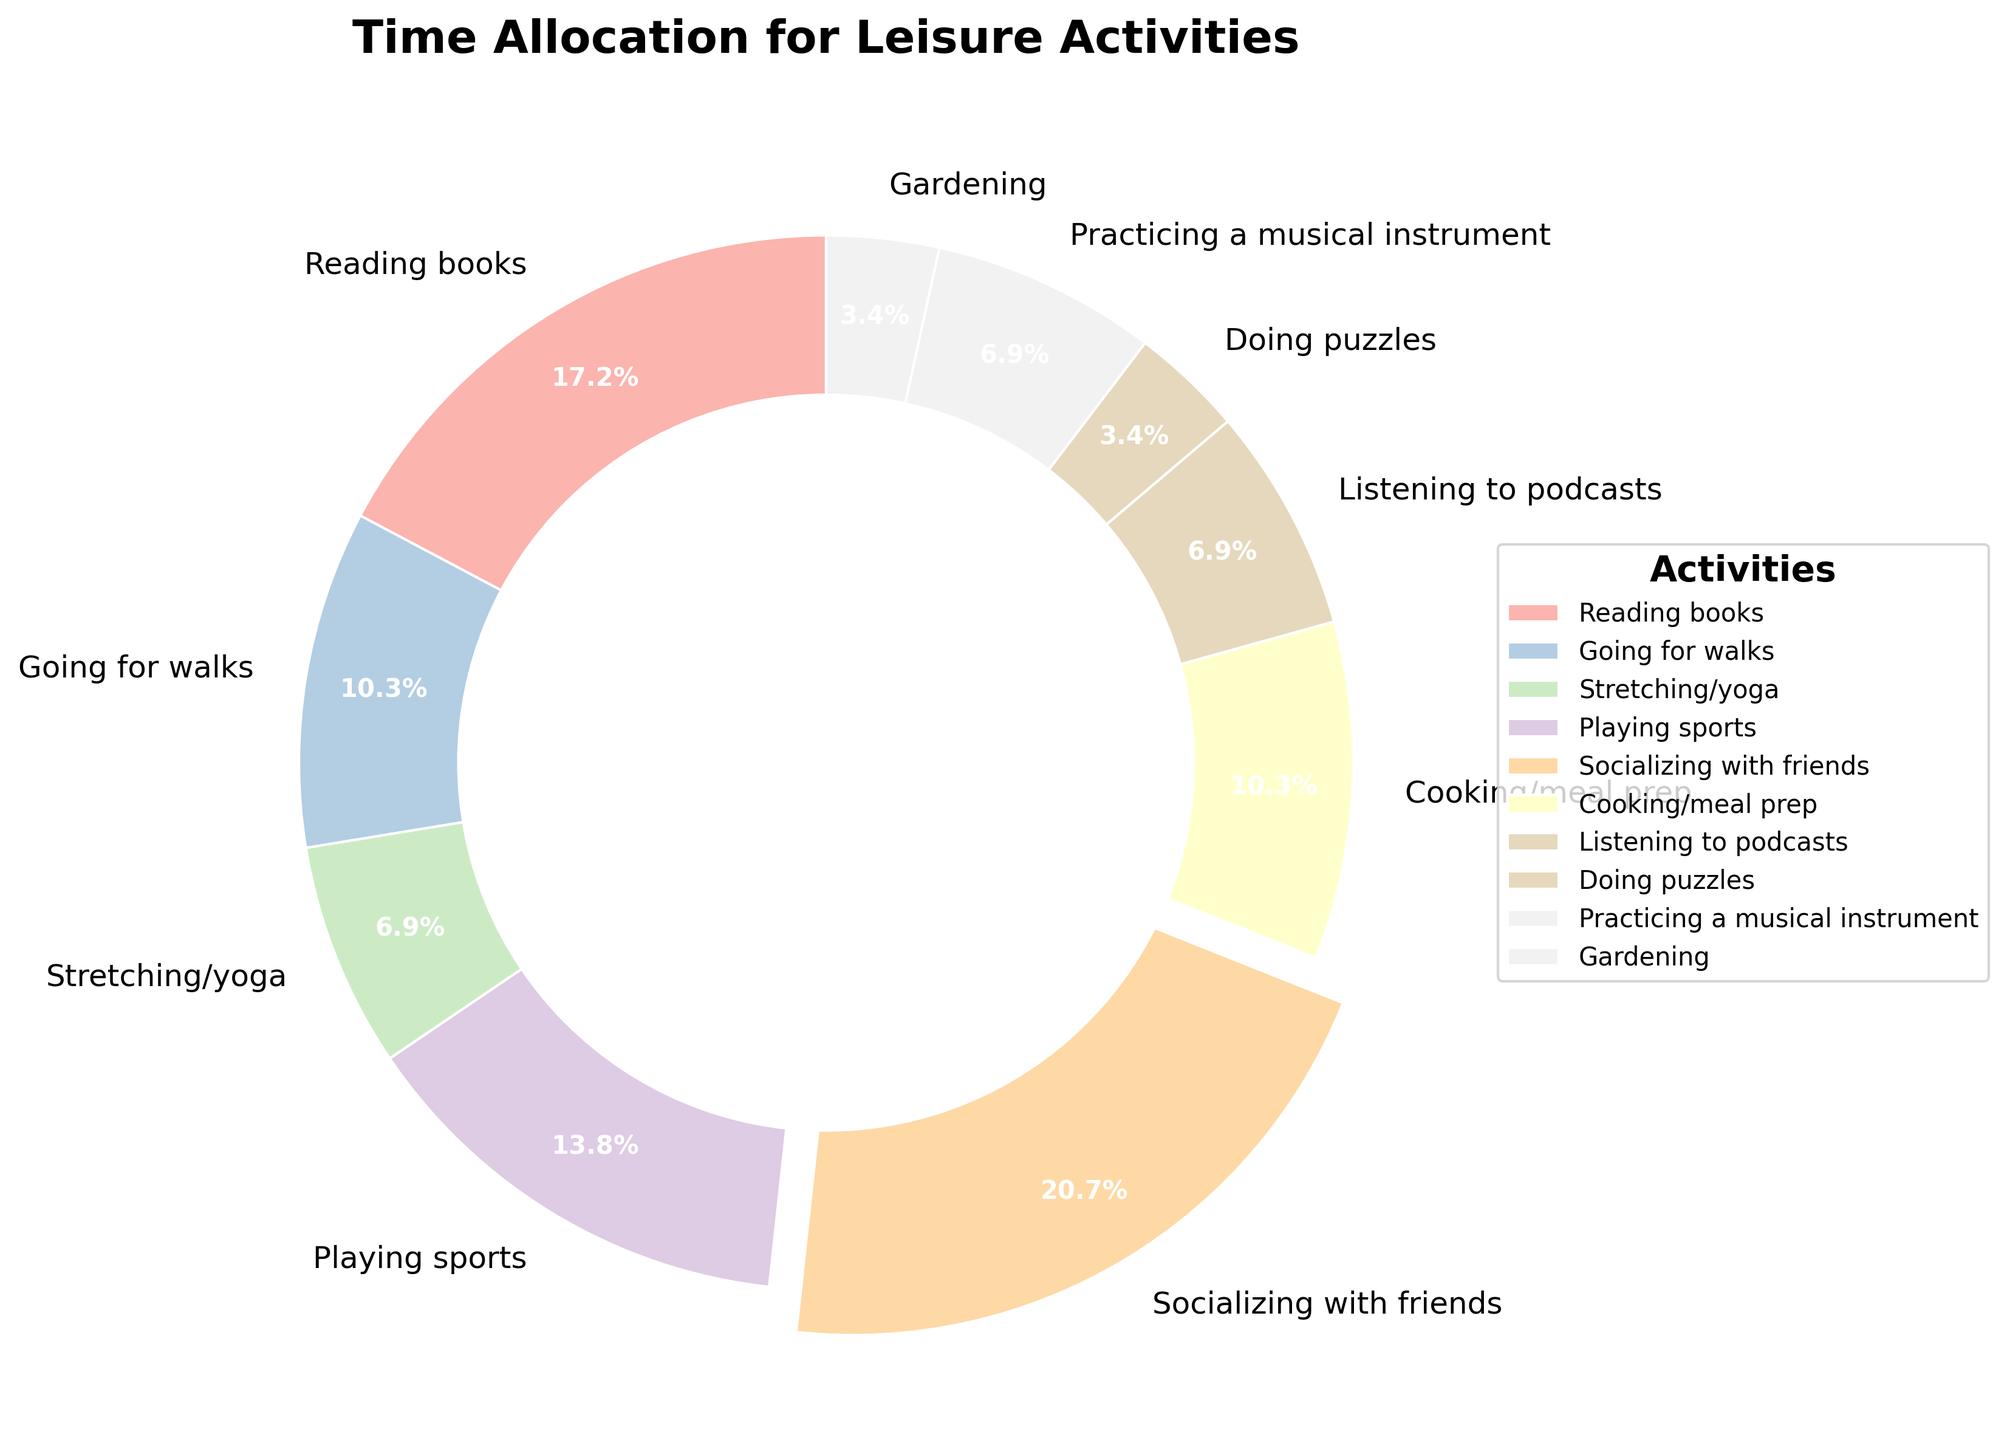Which activity takes up the most hours? The activity with the highest percentage on the pie chart takes up the most hours. This can be determined by finding the segment with the largest visual area and the percentage value. The slice for "Socializing with friends" is the largest and shows 29.3%.
Answer: Socializing with friends How many total hours are spent on physical activities? Identify and sum the hours spent on activities related to physical exertion: Going for walks (3), Stretching/yoga (2), and Playing sports (4). This yields 3 + 2 + 4.
Answer: 9 Which two activities have equal time allocation? Find the activities that have the same section size indicating equal hours. The chart shows that Stretching/yoga and Listening to podcasts both share 2 hours each.
Answer: Stretching/yoga and Listening to podcasts What is the second most time-consuming activity? Locate the second largest segment by visual inspection and percentage value. The largest segment is "Socializing with friends," and the second largest is "Reading books" with 5 hours.
Answer: Reading books What percentage of time is spent on Cooking/meal prep? Find the segment labeled Cooking/meal prep and read off the percentage value displayed in or near this segment. The value shown is 14.6%.
Answer: 14.6% Are more hours spent on Reading books than Playing sports? Compare the segments for Reading books (5 hours) and Playing sports (4 hours) by visual size and labeled hours. Reading books has more hours than Playing sports.
Answer: Yes What's the difference in hours between Going for walks and Gardening? Subtract the hours for Gardening (1) from the hours for Going for walks (3). The difference is 3 - 1.
Answer: 2 Which activity has nearly the smallest share, and what is that activity? Identify the second smallest segment after the smallest (Doing puzzles, 1 hour). Observing, the Gardening segment is the second smallest with 1 hour.
Answer: Gardening What is the combined percentage of time spent on Reading books and Listening to podcasts? Add the percentages for these activities: Reading books (24.4%) and Listening to podcasts (9.8%). The sum is 24.4% + 9.8%.
Answer: 34.2% How many activities have a time allocation of 2 hours or less? Count the segments that represent two hours or less: Stretching/yoga (2), Listening to podcasts (2), Doing puzzles (1), and Gardening (1). The total number is 4.
Answer: 4 